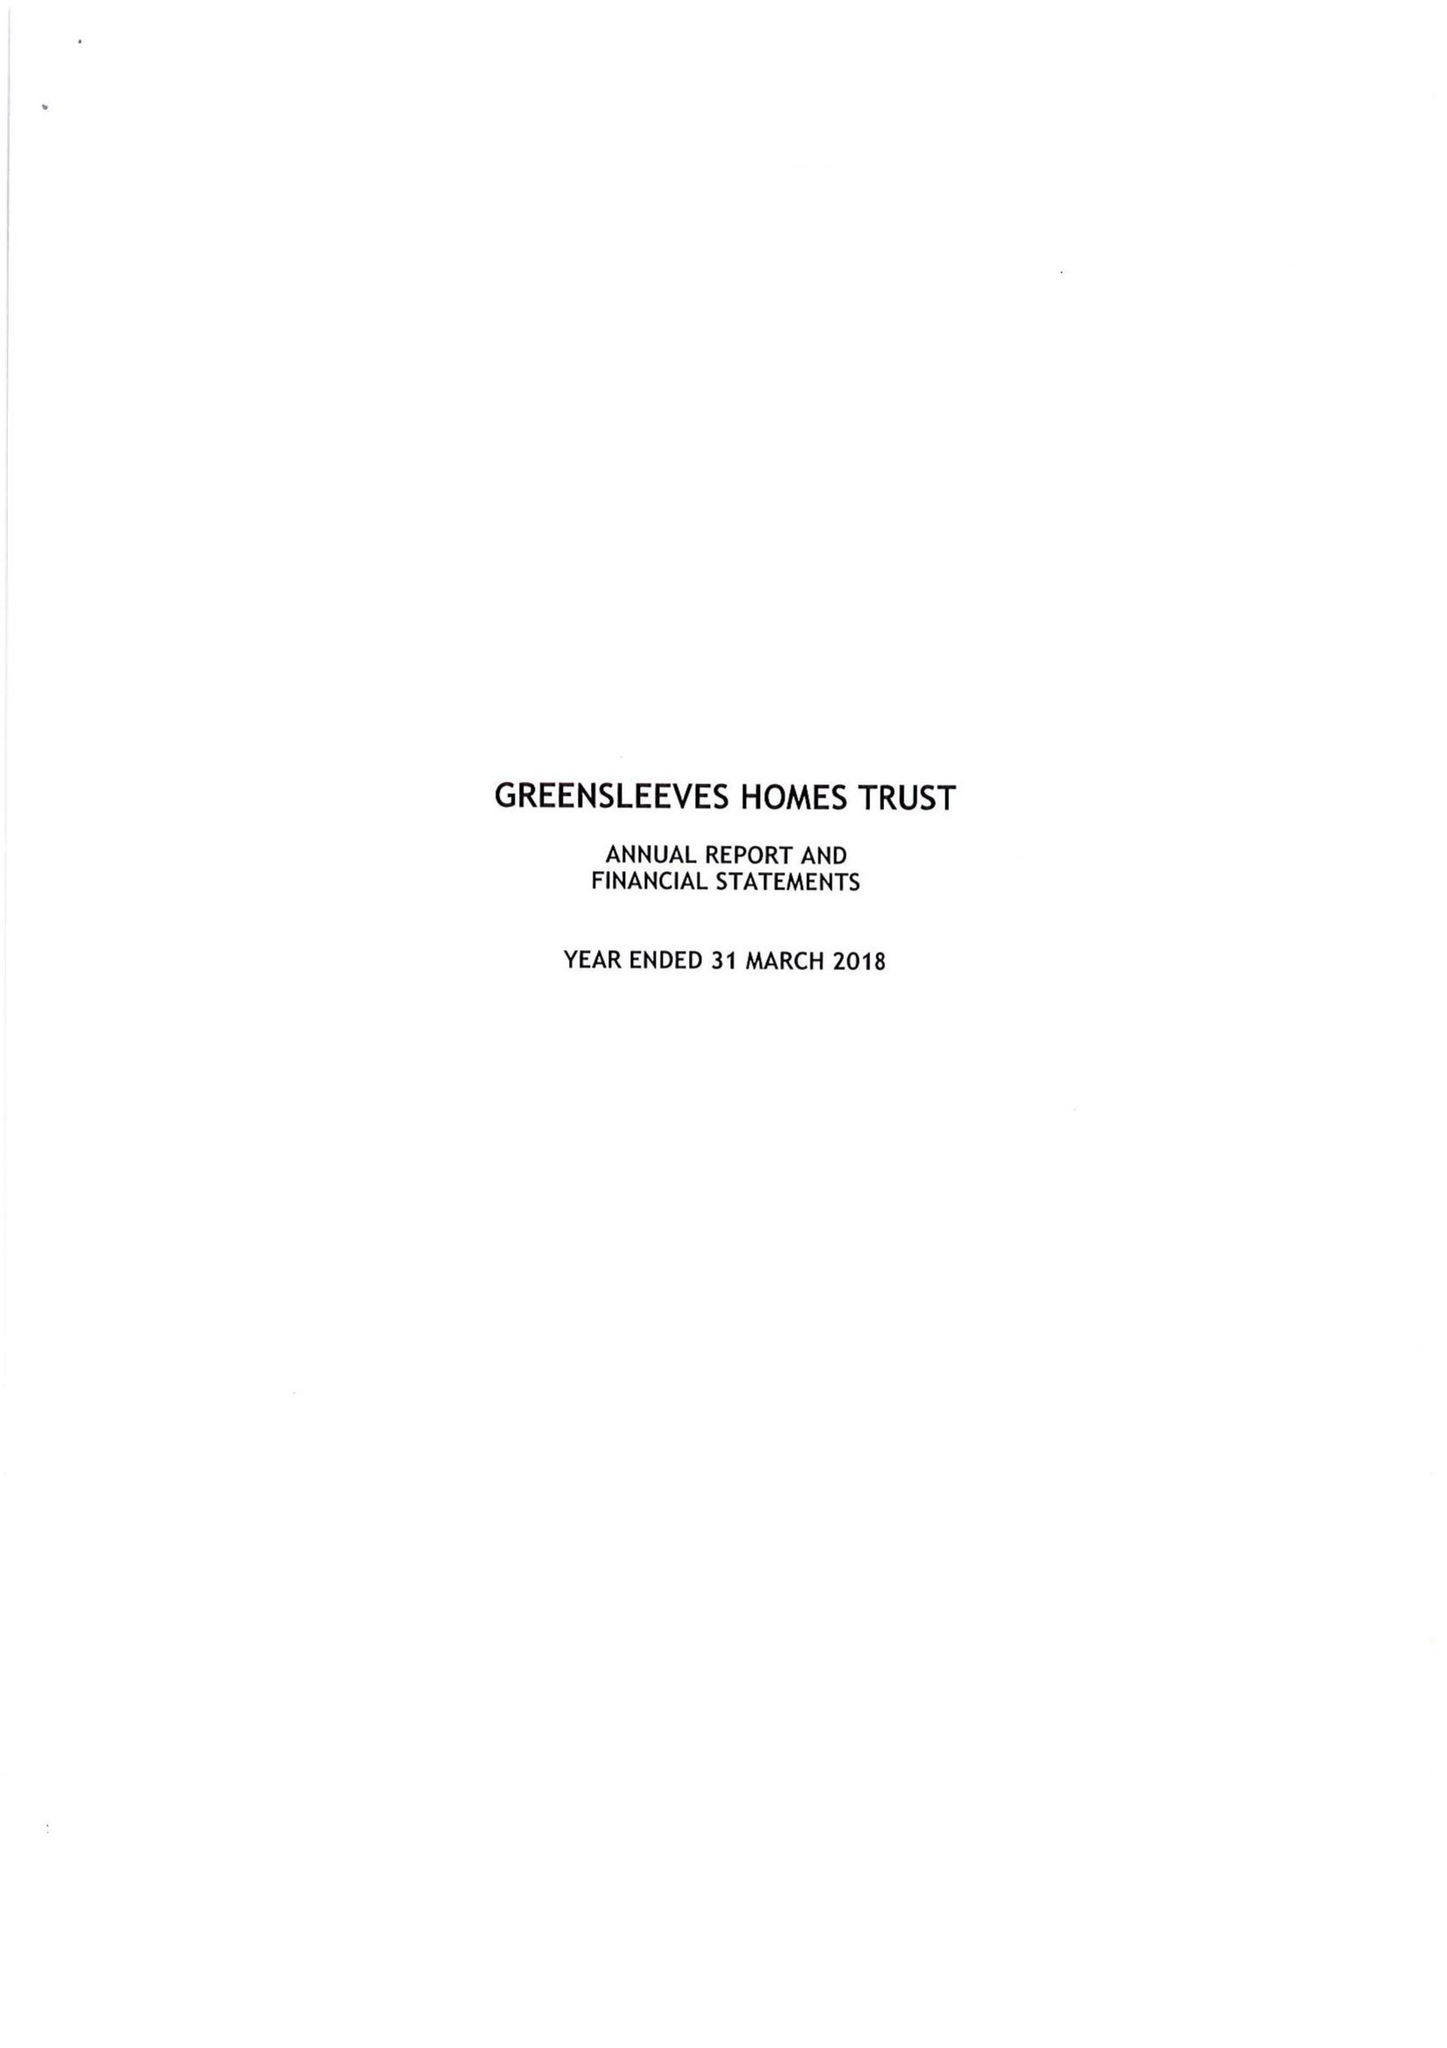What is the value for the address__street_line?
Answer the question using a single word or phrase. 54 FENCHURCH STREET 